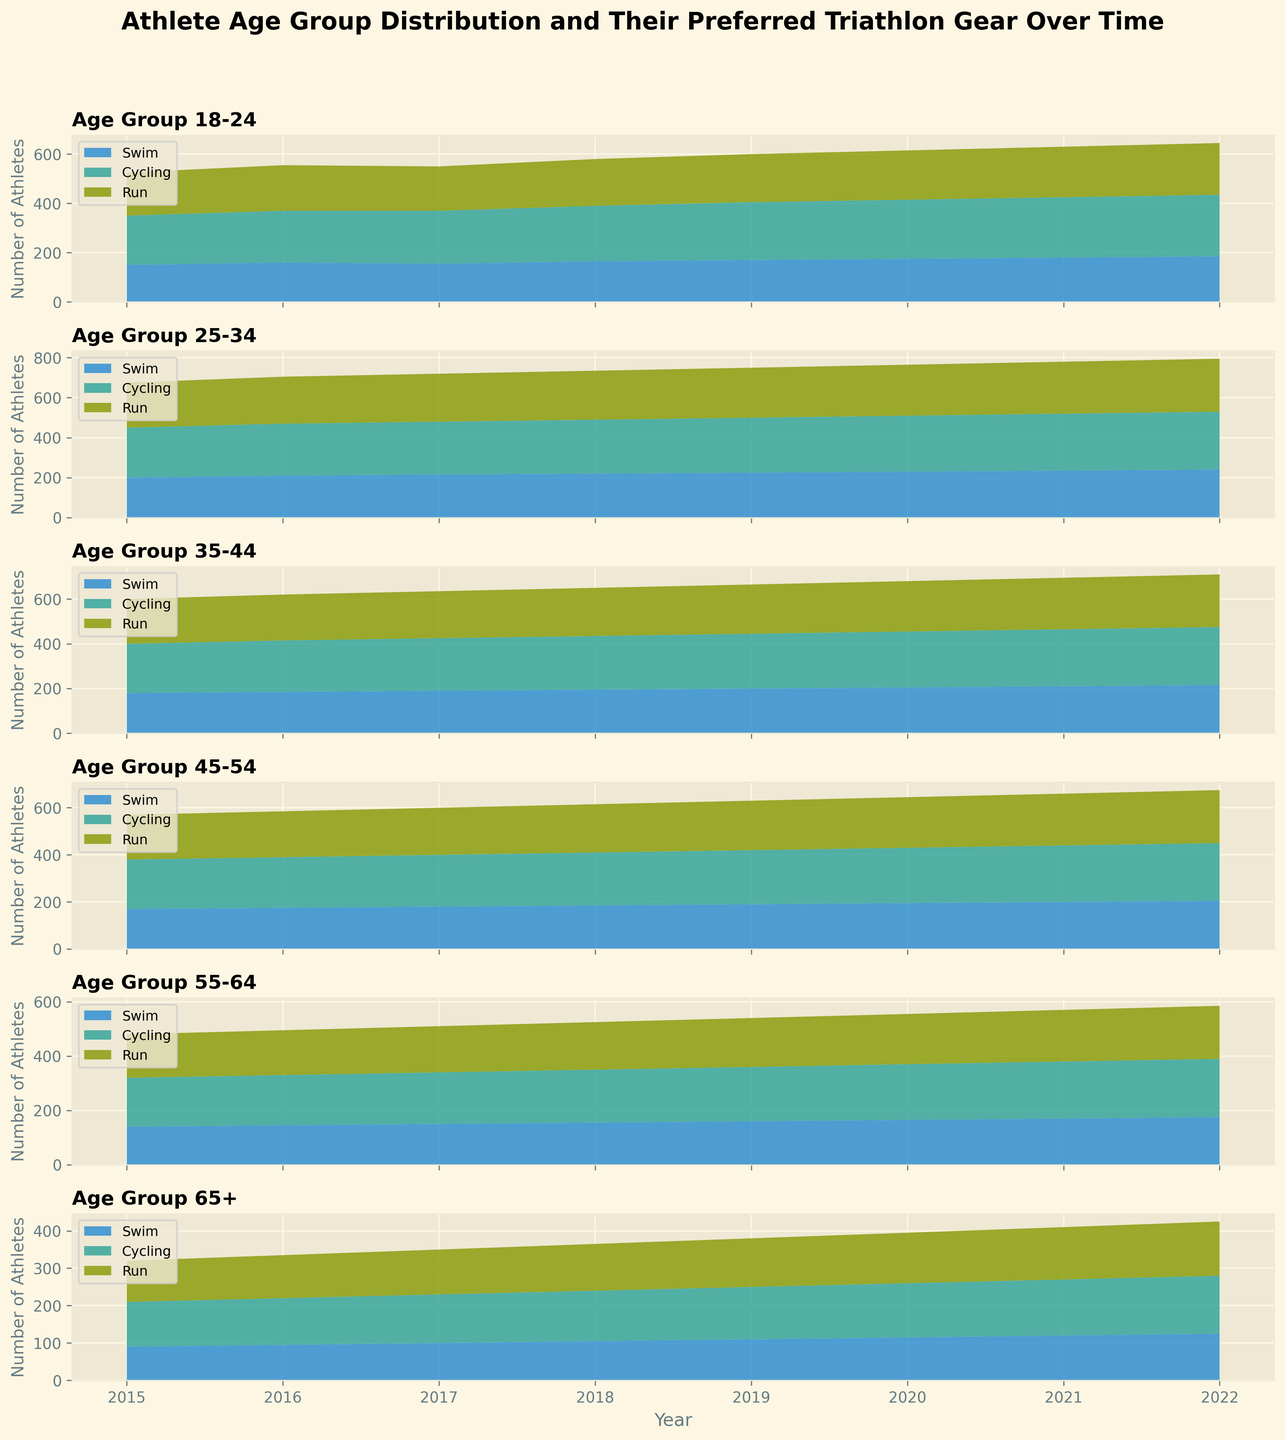What could be the trend for the preferred run gear in the 25-34 age group? The preferred run gear in the 25-34 age group has shown a steady increase from 225 in 2015 to 265 in 2022. This indicates a growing popularity for run gear among this age group.
Answer: Increasing trend Which age group had the highest preference for cycling gear in 2020? By examining the highest point in the stacked area for the year 2020, it is visible that the 25-34 age group had the highest preference for cycling gear compared to other groups.
Answer: 25-34 Comparing 2016 and 2022, which age group showed the largest increase in swim gear preference? By finding the difference in the number of swimmers between 2016 and 2022 for each age group, the 18-24 age group increased from 160 to 185, i.e., an increase of 25, which is the largest among all groups.
Answer: 18-24 What is the total number of athletes across all age groups for the preferred cycling gear in 2019? Adding the data for all age groups in 2019 for cycling: 235 (18-24) + 275 (25-34) + 245 (35-44) + 230 (45-54) + 200 (55-64) + 140 (65+). Therefore, the total is 1325.
Answer: 1325 Between age groups 35-44 and 45-54, which shows a greater increase in run gear preference from 2015 to 2022? By calculating the increase for each group: 35-44 increases from 200 in 2015 to 235 in 2022, an increase of 35. The 45-54 group increases from 190 to 225, an increase of 35 as well. Both groups show the same increase in preference.
Answer: Both groups are equal For the age group 65+, which year shows the greatest increase in total number of athletes compared to the previous year? Calculting the annual increase for 65+ age group: 2016-2015 (95-90)=5, 2017-2016 (100-95)=5, 2018-2017 (105-100)=5, 2019-2018 (110-105)=5, 2020-2019 (115-110)=5, 2021-2020 (120-115)=5, 2022-2021 (125-120)=5. The increases are consistent at 5 each year.
Answer: Any year, consistent increase In 2022, what percentage of athletes in the 25-34 age group preferred swimming gear? Summing up the total athletes in 2022 for the 25-34 age group: 240 (swimming) + 290 (cycling) + 265 (run) = 795. The percentage for swimming is (240/795) * 100 ≈ 30.19%.
Answer: ≈ 30.19% What are the predominant activity preferences in the age group 55-64 over the years? By observing the stack heights, cycling has slightly more athletes compared to swim and run, indicating cycling is the predominant preference over the years.
Answer: Cycling Which age group showed the least fluctuation in their preferred gear from 2015 to 2022? Looking at the relatively consistent stack heights, the 65+ age group shows the least fluctuation across all gear preferences over the years.
Answer: 65+ 